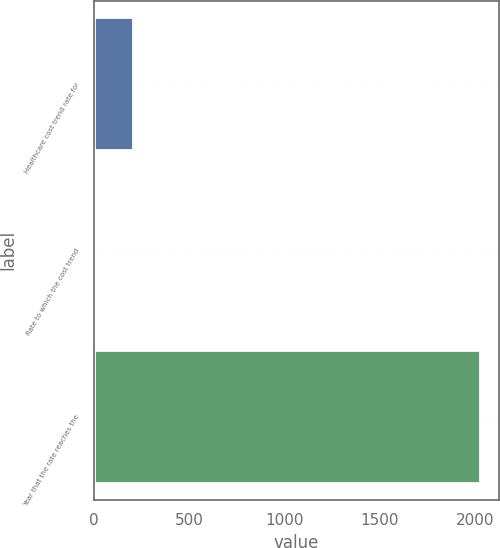Convert chart to OTSL. <chart><loc_0><loc_0><loc_500><loc_500><bar_chart><fcel>Healthcare cost trend rate for<fcel>Rate to which the cost trend<fcel>Year that the rate reaches the<nl><fcel>206.6<fcel>5<fcel>2021<nl></chart> 